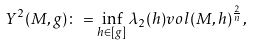Convert formula to latex. <formula><loc_0><loc_0><loc_500><loc_500>Y ^ { 2 } ( M , g ) \colon = \inf _ { h \in [ g ] } \lambda _ { 2 } ( h ) v o l ( M , h ) ^ { \frac { 2 } { n } } ,</formula> 